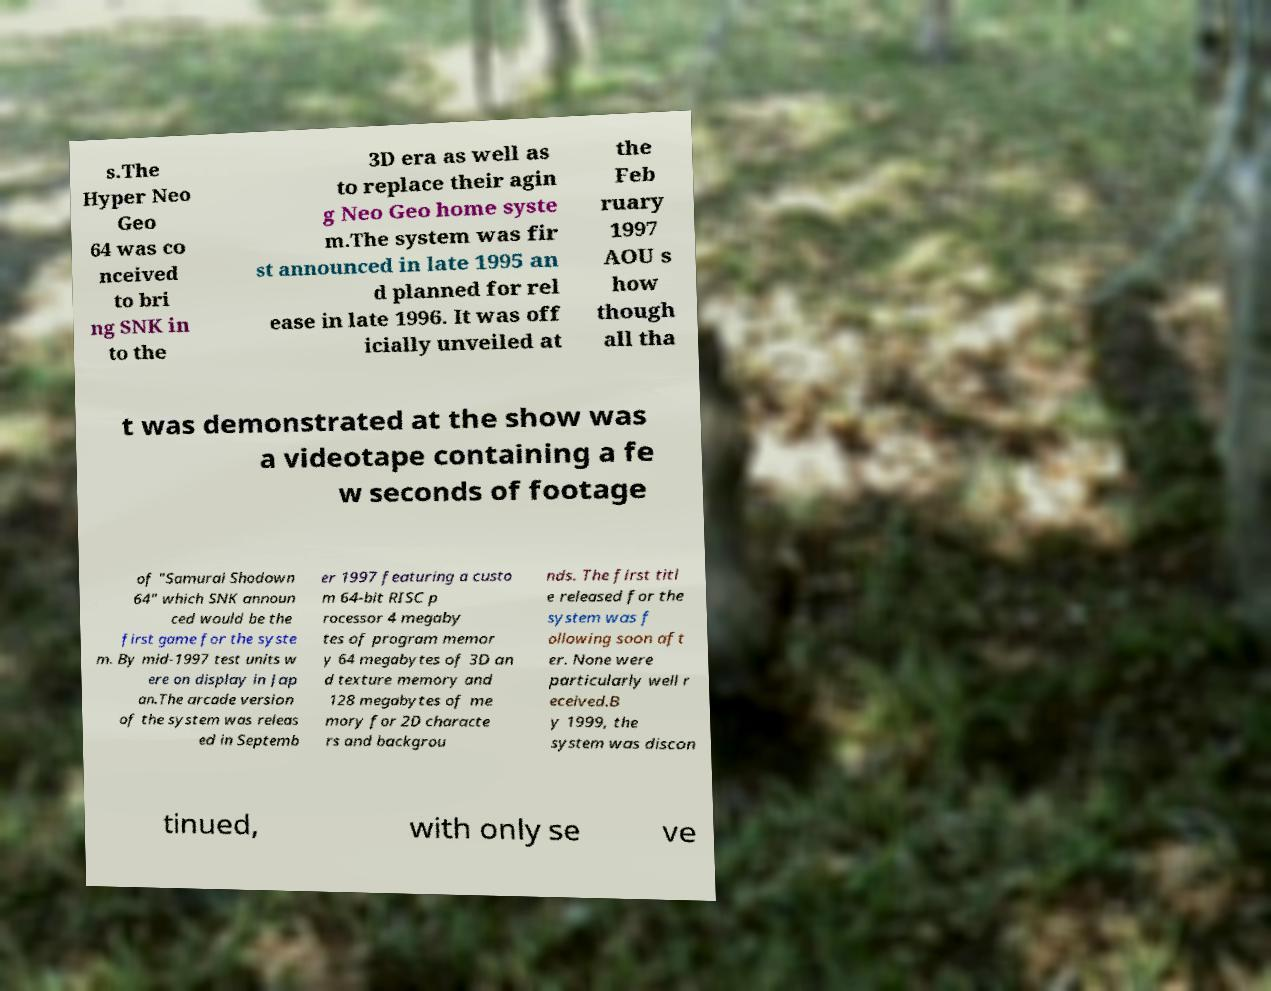Can you read and provide the text displayed in the image?This photo seems to have some interesting text. Can you extract and type it out for me? s.The Hyper Neo Geo 64 was co nceived to bri ng SNK in to the 3D era as well as to replace their agin g Neo Geo home syste m.The system was fir st announced in late 1995 an d planned for rel ease in late 1996. It was off icially unveiled at the Feb ruary 1997 AOU s how though all tha t was demonstrated at the show was a videotape containing a fe w seconds of footage of "Samurai Shodown 64" which SNK announ ced would be the first game for the syste m. By mid-1997 test units w ere on display in Jap an.The arcade version of the system was releas ed in Septemb er 1997 featuring a custo m 64-bit RISC p rocessor 4 megaby tes of program memor y 64 megabytes of 3D an d texture memory and 128 megabytes of me mory for 2D characte rs and backgrou nds. The first titl e released for the system was f ollowing soon aft er. None were particularly well r eceived.B y 1999, the system was discon tinued, with only se ve 